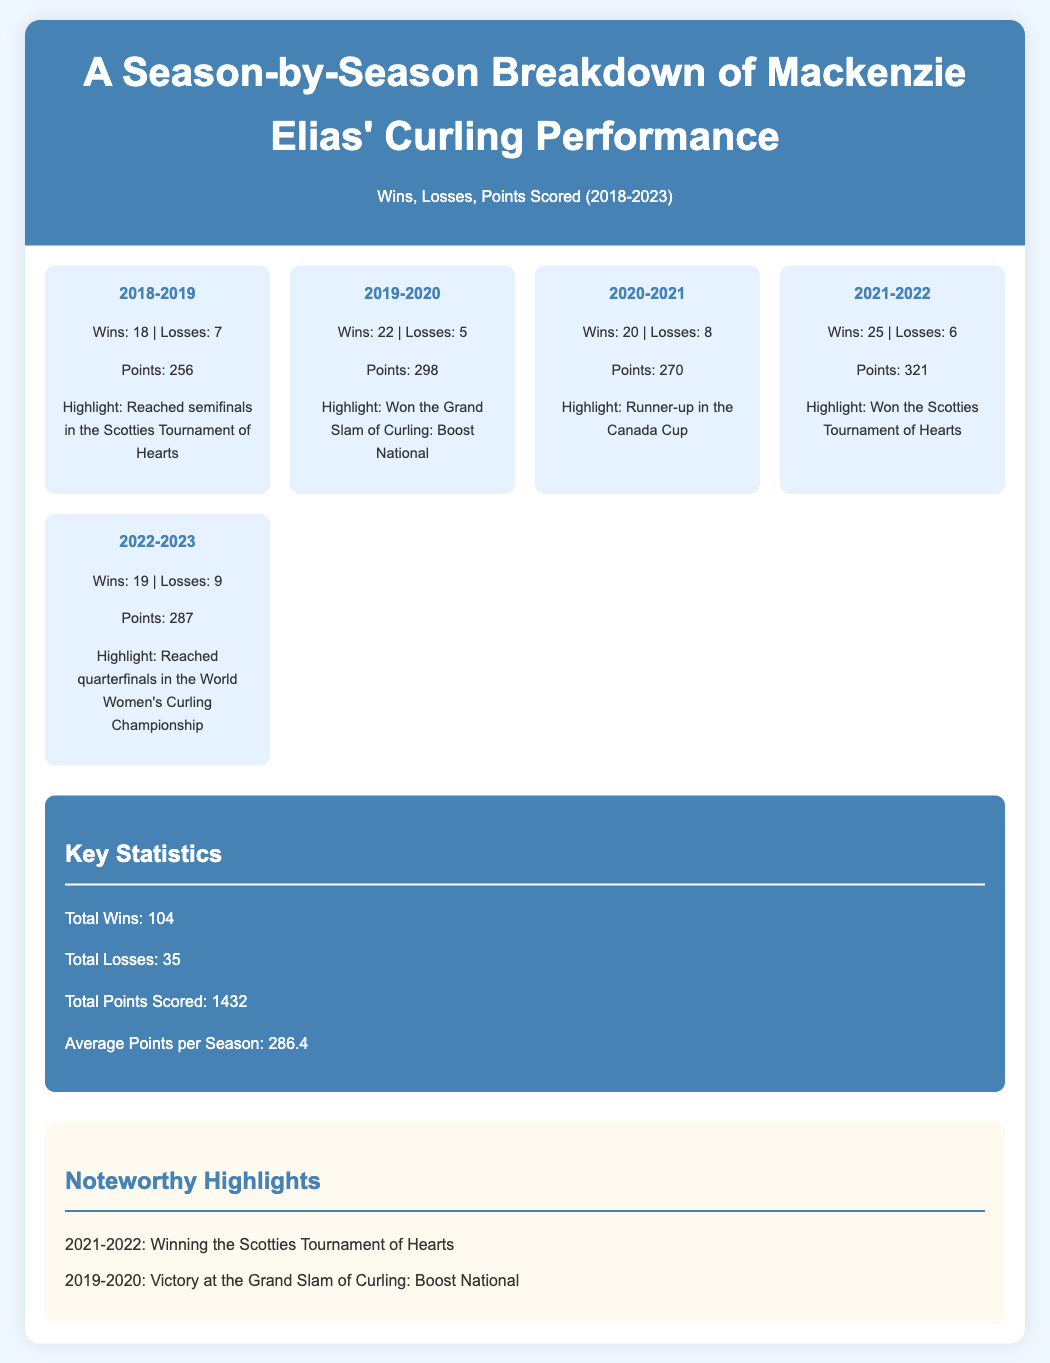What was Mackenzie Elias' win-loss record in 2019-2020? The document provides Mackenzie Elias' performance for each season, including her wins and losses for 2019-2020, which are 22 wins and 5 losses.
Answer: 22 wins, 5 losses What highlight did Mackenzie achieve in the 2021-2022 season? The infographic mentions significant highlights for each season, stating she won the Scotties Tournament of Hearts in 2021-2022.
Answer: Won the Scotties Tournament of Hearts How many total points did Mackenzie score in the 2020-2021 season? The infographic lists points scored for each season, showing that she scored 270 points in the 2020-2021 season.
Answer: 270 What is the average points per season scored by Mackenzie? The document summarizes key statistics, including the average points per season, calculated as total points divided by the number of seasons.
Answer: 286.4 What was the total number of losses across all seasons? The key statistics section lists total losses from all seasons, which is 35.
Answer: 35 In which season did Mackenzie have the highest number of wins? The infographic presents the win-loss records for each season, indicating that 2021-2022 had the highest wins at 25.
Answer: 2021-2022 What notable event occurred in 2019-2020? The highlights section of the document discusses notable achievements, revealing she won the Grand Slam of Curling: Boost National in 2019-2020.
Answer: Won the Grand Slam of Curling: Boost National What is the total number of wins by Mackenzie Elias from 2018 to 2023? The document provides a summary of key statistics, revealing the total number of wins over the seasons is 104.
Answer: 104 